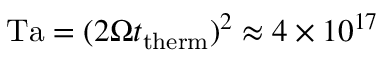Convert formula to latex. <formula><loc_0><loc_0><loc_500><loc_500>T a = ( 2 \Omega t _ { t h e r m } ) ^ { 2 } \approx 4 \times 1 0 ^ { 1 7 }</formula> 